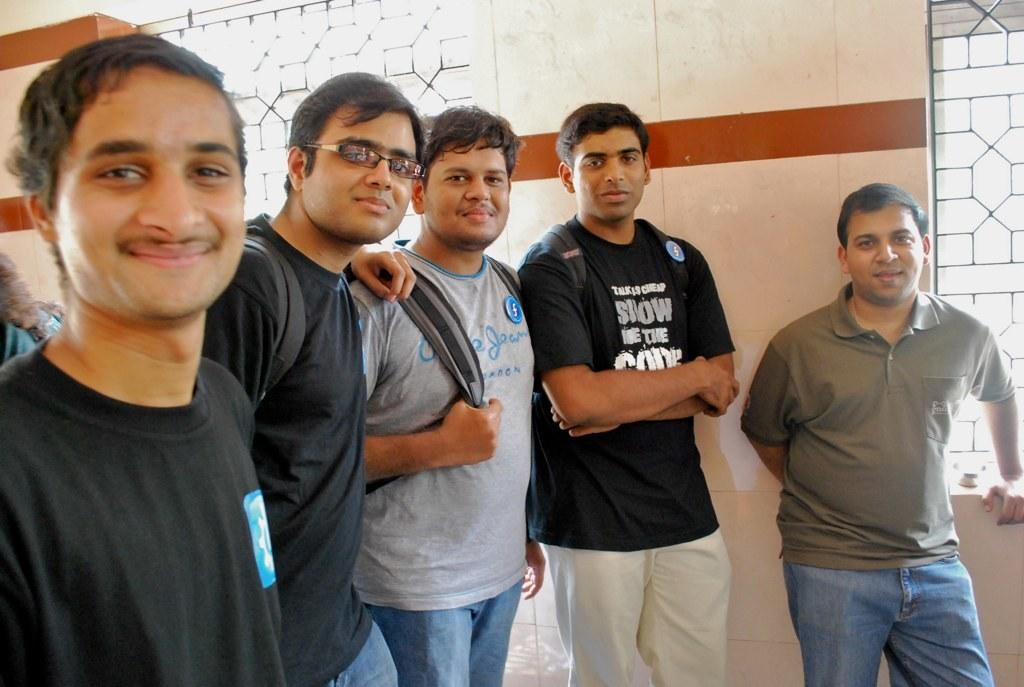What are the people in the image doing? The people in the image are standing in the center and smiling. What can be seen in the background of the image? There is a wall and grills visible in the background of the image. How many servants are attending to the people in the image? There are no servants present in the image. What type of insect can be seen crawling on the grills in the image? There are no insects visible in the image, and the grills are not in focus enough to see any insects. 